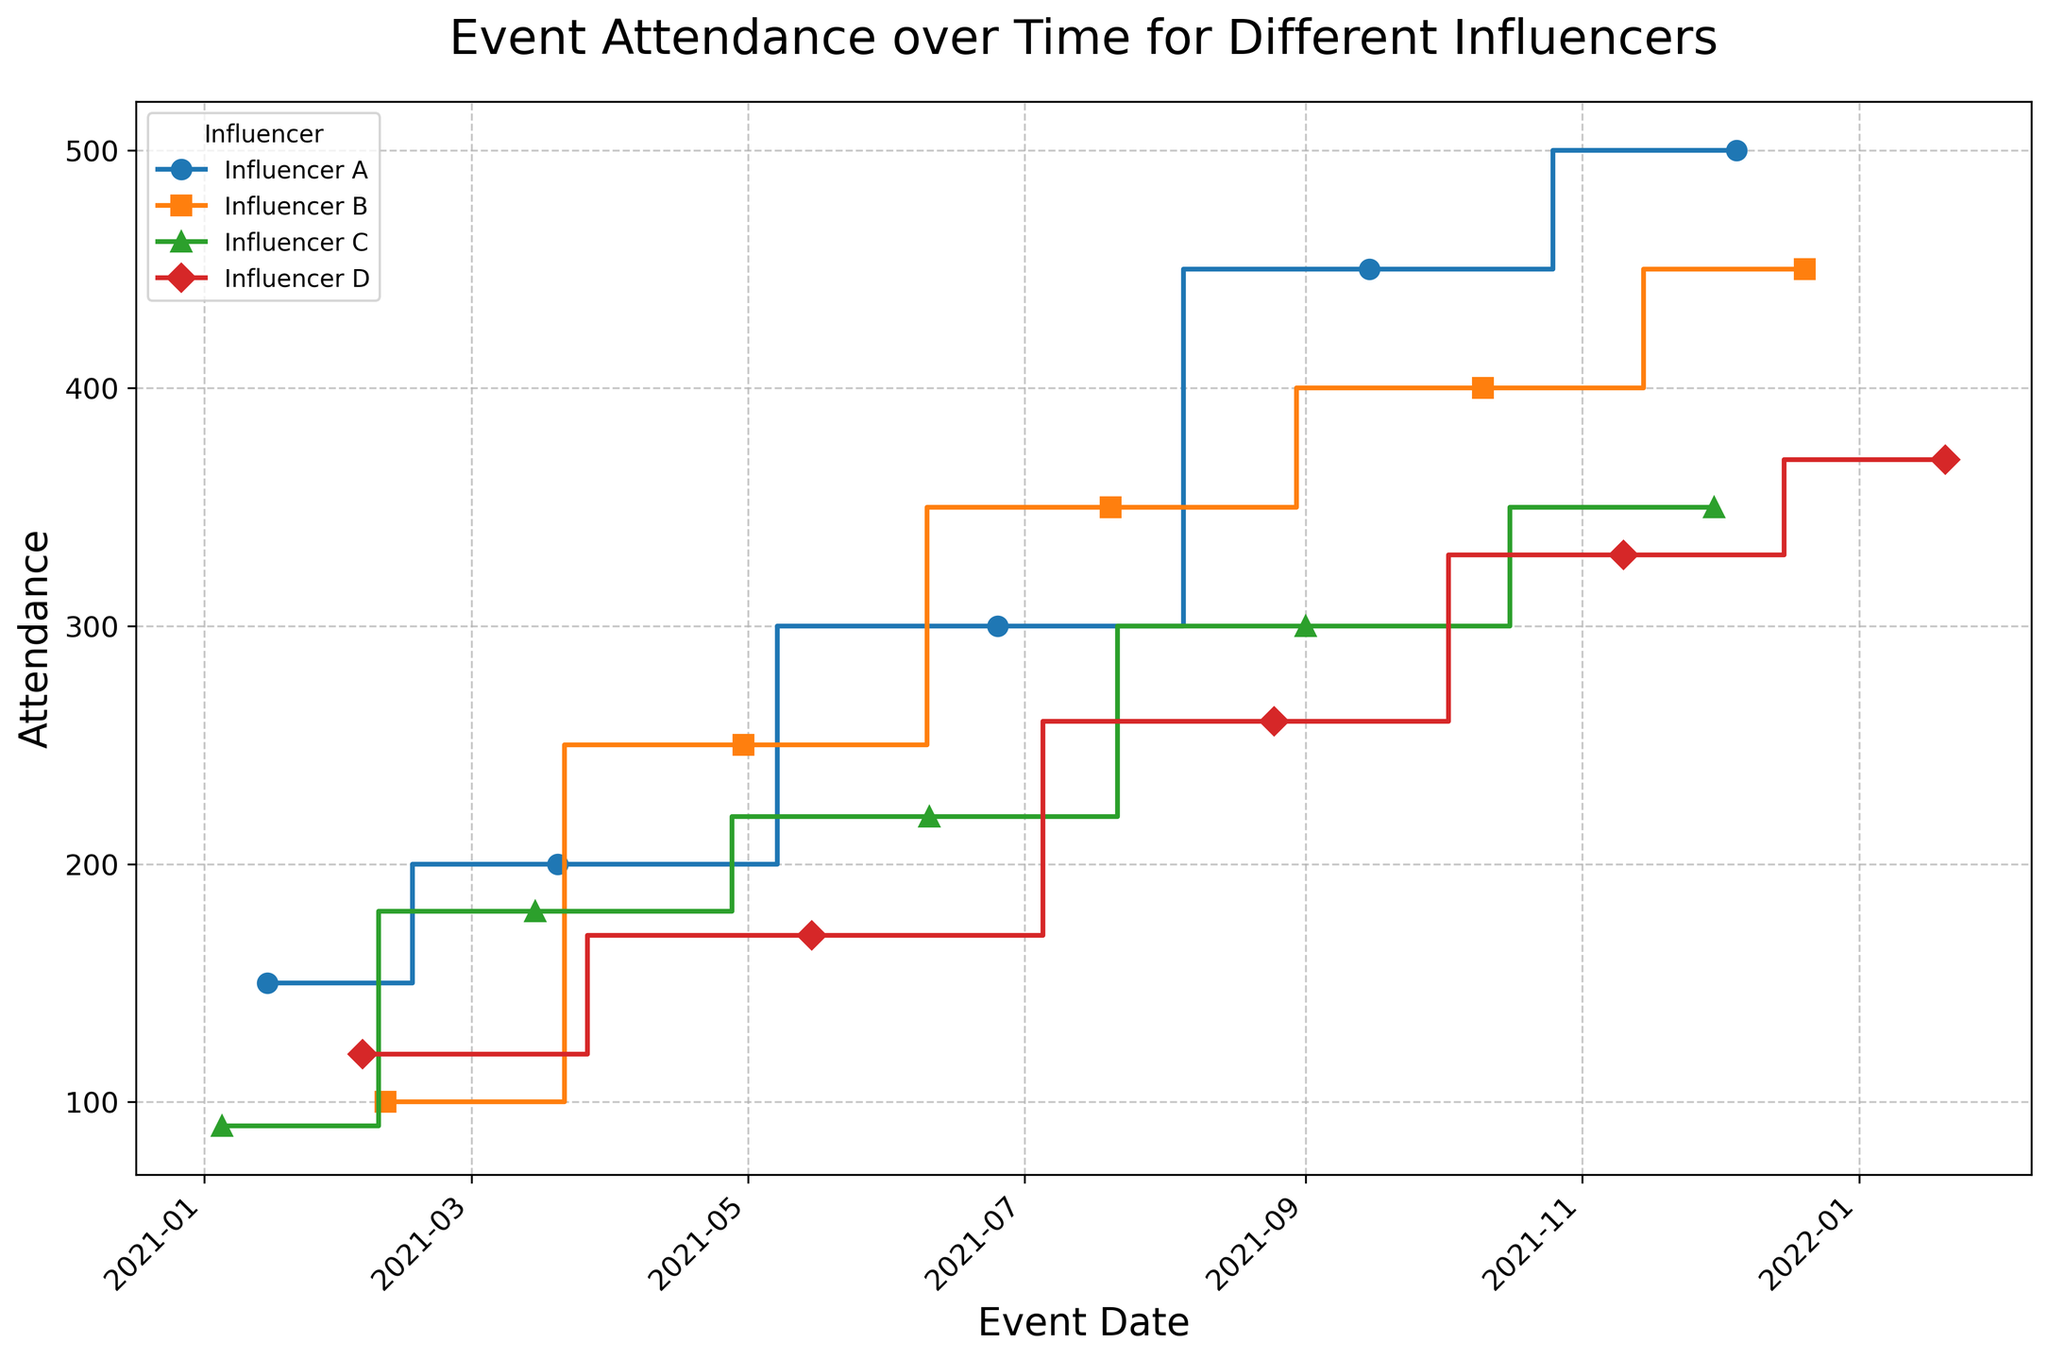Which influencer had the highest attendance at any event? By observing the plot, the highest peak represents the maximum attendance, which for Influencer A was at 500 on the event date 2021-12-05.
Answer: Influencer A How did Influencer B's attendance compare between their first and last events? For Influencer B, the first event had an attendance of 100 (2021-02-10) and the last event had an attendance of 450 (2021-12-20). The increase from 100 to 450 shows significant growth.
Answer: Attendance increased from 100 to 450 What is the trend for Influencer C's event attendance over time? Observing Influencer C’s step plot, the attendance steadily increased from 90 in January to 350 by the end of November. The upward trend is consistent through all events.
Answer: Steadily increasing Who had the most consistent attendance growth? Influencer D shows the most uniform increments in attendance over time compared to other influencers, whose plots have varied slopes and larger jumps.
Answer: Influencer D Which month saw the highest cumulative attendance across all influencers? Summing up all events in each month across all influencers reveals that December has the highest cumulative attendance. Combined data points from December: 500 (A) + 450 (B) + 350 (C) = 1300.
Answer: December Did any influencer experience a drop in attendance for any event? Reviewing all step plots, no influencer experienced a drop in attendance; all trends are either steady or increasing over time.
Answer: No Compare attendance in midyear events (June-July): Who had the highest and who had the lowest? In June and July, Influencer A had 300 (June), Influencer B had 350 (July), Influencer C had 220 (June), Influencer D had 260 (August). Influencer B had the highest, and Influencer C had the lowest attendance.
Answer: Highest: Influencer B, Lowest: Influencer C How much did Influencer D’s attendance grow from the second to the fourth event? Influencer D’s attendance on the second event (170 on 2021-05-15) and fourth event (330 on 2021-11-10). The growth is 330 - 170 = 160.
Answer: 160 Which influencer attracted a gradually increasing audience without any big jumps? By analyzing each influencer’s steps, Influencer D has a smooth increasing pattern compared to significant jumps observed in other plots.
Answer: Influencer D 